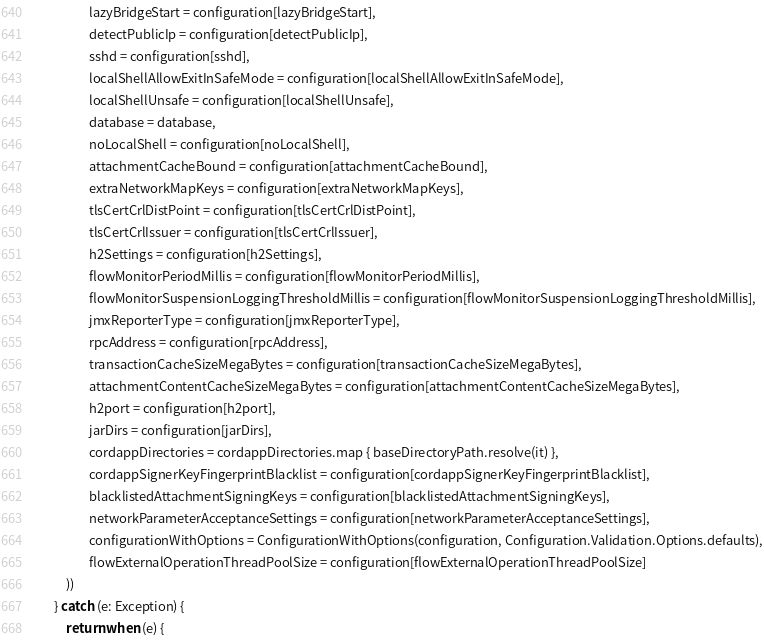Convert code to text. <code><loc_0><loc_0><loc_500><loc_500><_Kotlin_>                    lazyBridgeStart = configuration[lazyBridgeStart],
                    detectPublicIp = configuration[detectPublicIp],
                    sshd = configuration[sshd],
                    localShellAllowExitInSafeMode = configuration[localShellAllowExitInSafeMode],
                    localShellUnsafe = configuration[localShellUnsafe],
                    database = database,
                    noLocalShell = configuration[noLocalShell],
                    attachmentCacheBound = configuration[attachmentCacheBound],
                    extraNetworkMapKeys = configuration[extraNetworkMapKeys],
                    tlsCertCrlDistPoint = configuration[tlsCertCrlDistPoint],
                    tlsCertCrlIssuer = configuration[tlsCertCrlIssuer],
                    h2Settings = configuration[h2Settings],
                    flowMonitorPeriodMillis = configuration[flowMonitorPeriodMillis],
                    flowMonitorSuspensionLoggingThresholdMillis = configuration[flowMonitorSuspensionLoggingThresholdMillis],
                    jmxReporterType = configuration[jmxReporterType],
                    rpcAddress = configuration[rpcAddress],
                    transactionCacheSizeMegaBytes = configuration[transactionCacheSizeMegaBytes],
                    attachmentContentCacheSizeMegaBytes = configuration[attachmentContentCacheSizeMegaBytes],
                    h2port = configuration[h2port],
                    jarDirs = configuration[jarDirs],
                    cordappDirectories = cordappDirectories.map { baseDirectoryPath.resolve(it) },
                    cordappSignerKeyFingerprintBlacklist = configuration[cordappSignerKeyFingerprintBlacklist],
                    blacklistedAttachmentSigningKeys = configuration[blacklistedAttachmentSigningKeys],
                    networkParameterAcceptanceSettings = configuration[networkParameterAcceptanceSettings],
                    configurationWithOptions = ConfigurationWithOptions(configuration, Configuration.Validation.Options.defaults),
                    flowExternalOperationThreadPoolSize = configuration[flowExternalOperationThreadPoolSize]
            ))
        } catch (e: Exception) {
            return when (e) {</code> 